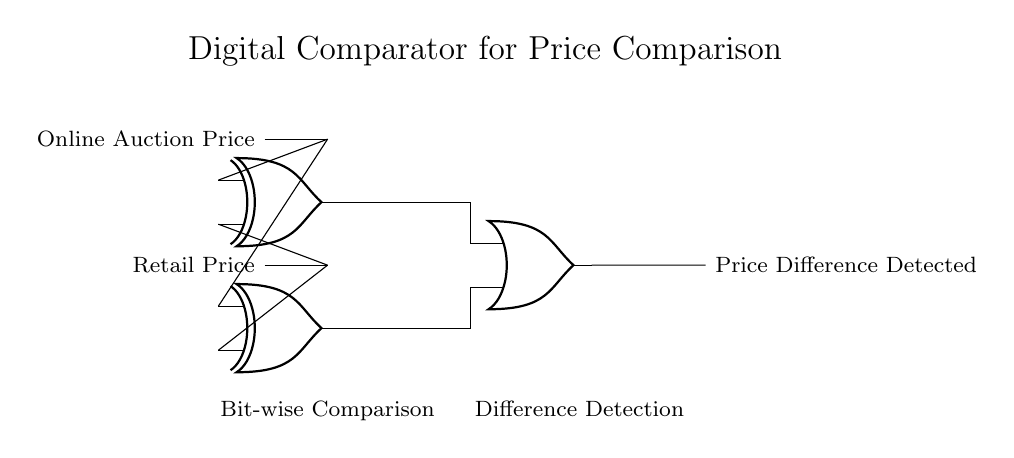What are the inputs to the XOR gates? The inputs to the XOR gates are the Online Auction Price and the Retail Price, which are represented as two separate lines entering each of the two XOR gates.
Answer: Online Auction Price, Retail Price How many XOR gates are there in this circuit? The circuit features two XOR gates. Each gate compares the same pair of inputs (Online Auction Price and Retail Price).
Answer: Two What does the output of the OR gate indicate? The output of the OR gate indicates whether there is a price difference detected between the two compared prices, meaning any difference at either XOR gate results in a high output at the OR gate.
Answer: Price Difference Detected Why are XOR gates used in this circuit? XOR gates are used because they output a high signal (true) when the input signals are different, making them suitable for detecting differences between the Online Auction Price and the Retail Price.
Answer: To detect differences What is the role of the OR gate in this comparator circuit? The OR gate collects the outputs from both XOR gates, producing a single output that signifies whether at least one of the comparisons detected a price difference, thus serving as a summarizer for the circuit results.
Answer: Difference Detection 